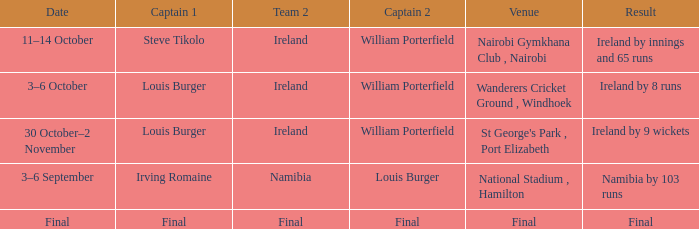Which Captain 2 has a Result of ireland by 8 runs? William Porterfield. 